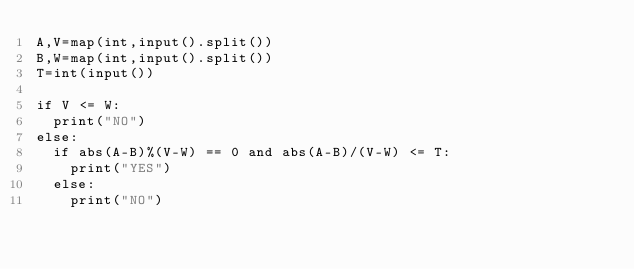Convert code to text. <code><loc_0><loc_0><loc_500><loc_500><_Python_>A,V=map(int,input().split())
B,W=map(int,input().split())
T=int(input())

if V <= W:
  print("NO")
else:
  if abs(A-B)%(V-W) == 0 and abs(A-B)/(V-W) <= T:
    print("YES")
  else:
    print("NO")</code> 